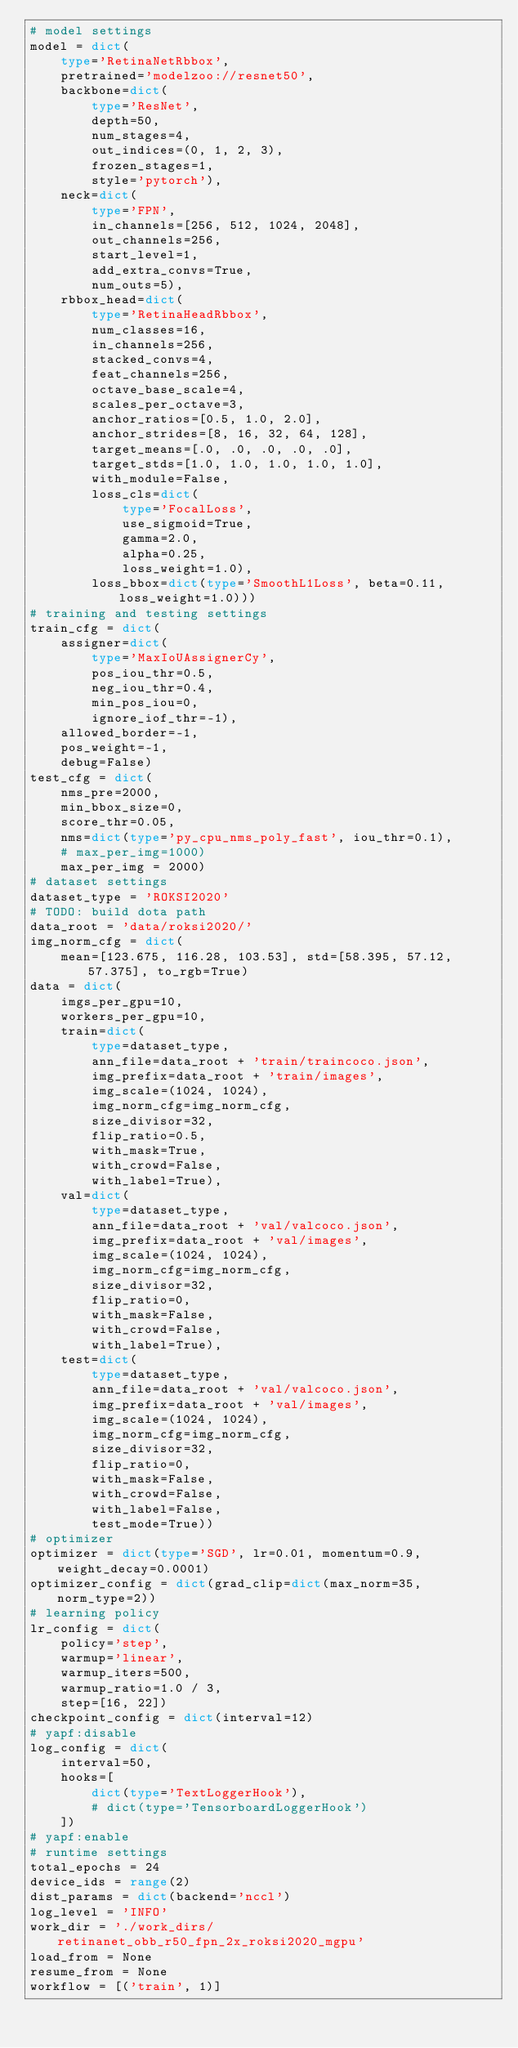<code> <loc_0><loc_0><loc_500><loc_500><_Python_># model settings
model = dict(
    type='RetinaNetRbbox',
    pretrained='modelzoo://resnet50',
    backbone=dict(
        type='ResNet',
        depth=50,
        num_stages=4,
        out_indices=(0, 1, 2, 3),
        frozen_stages=1,
        style='pytorch'),
    neck=dict(
        type='FPN',
        in_channels=[256, 512, 1024, 2048],
        out_channels=256,
        start_level=1,
        add_extra_convs=True,
        num_outs=5),
    rbbox_head=dict(
        type='RetinaHeadRbbox',
        num_classes=16,
        in_channels=256,
        stacked_convs=4,
        feat_channels=256,
        octave_base_scale=4,
        scales_per_octave=3,
        anchor_ratios=[0.5, 1.0, 2.0],
        anchor_strides=[8, 16, 32, 64, 128],
        target_means=[.0, .0, .0, .0, .0],
        target_stds=[1.0, 1.0, 1.0, 1.0, 1.0],
        with_module=False,
        loss_cls=dict(
            type='FocalLoss',
            use_sigmoid=True,
            gamma=2.0,
            alpha=0.25,
            loss_weight=1.0),
        loss_bbox=dict(type='SmoothL1Loss', beta=0.11, loss_weight=1.0)))
# training and testing settings
train_cfg = dict(
    assigner=dict(
        type='MaxIoUAssignerCy',
        pos_iou_thr=0.5,
        neg_iou_thr=0.4,
        min_pos_iou=0,
        ignore_iof_thr=-1),
    allowed_border=-1,
    pos_weight=-1,
    debug=False)
test_cfg = dict(
    nms_pre=2000,
    min_bbox_size=0,
    score_thr=0.05,
    nms=dict(type='py_cpu_nms_poly_fast', iou_thr=0.1),
    # max_per_img=1000)
    max_per_img = 2000)
# dataset settings
dataset_type = 'ROKSI2020'
# TODO: build dota path
data_root = 'data/roksi2020/'
img_norm_cfg = dict(
    mean=[123.675, 116.28, 103.53], std=[58.395, 57.12, 57.375], to_rgb=True)
data = dict(
    imgs_per_gpu=10,
    workers_per_gpu=10,
    train=dict(
        type=dataset_type,
        ann_file=data_root + 'train/traincoco.json',
        img_prefix=data_root + 'train/images',
        img_scale=(1024, 1024),
        img_norm_cfg=img_norm_cfg,
        size_divisor=32,
        flip_ratio=0.5,
        with_mask=True,
        with_crowd=False,
        with_label=True),
    val=dict(
        type=dataset_type,
        ann_file=data_root + 'val/valcoco.json',
        img_prefix=data_root + 'val/images',
        img_scale=(1024, 1024),
        img_norm_cfg=img_norm_cfg,
        size_divisor=32,
        flip_ratio=0,
        with_mask=False,
        with_crowd=False,
        with_label=True),
    test=dict(
        type=dataset_type,
        ann_file=data_root + 'val/valcoco.json',
        img_prefix=data_root + 'val/images',
        img_scale=(1024, 1024),
        img_norm_cfg=img_norm_cfg,
        size_divisor=32,
        flip_ratio=0,
        with_mask=False,
        with_crowd=False,
        with_label=False,
        test_mode=True))
# optimizer
optimizer = dict(type='SGD', lr=0.01, momentum=0.9, weight_decay=0.0001)
optimizer_config = dict(grad_clip=dict(max_norm=35, norm_type=2))
# learning policy
lr_config = dict(
    policy='step',
    warmup='linear',
    warmup_iters=500,
    warmup_ratio=1.0 / 3,
    step=[16, 22])
checkpoint_config = dict(interval=12)
# yapf:disable
log_config = dict(
    interval=50,
    hooks=[
        dict(type='TextLoggerHook'),
        # dict(type='TensorboardLoggerHook')
    ])
# yapf:enable
# runtime settings
total_epochs = 24
device_ids = range(2)
dist_params = dict(backend='nccl')
log_level = 'INFO'
work_dir = './work_dirs/retinanet_obb_r50_fpn_2x_roksi2020_mgpu'
load_from = None
resume_from = None
workflow = [('train', 1)]
</code> 